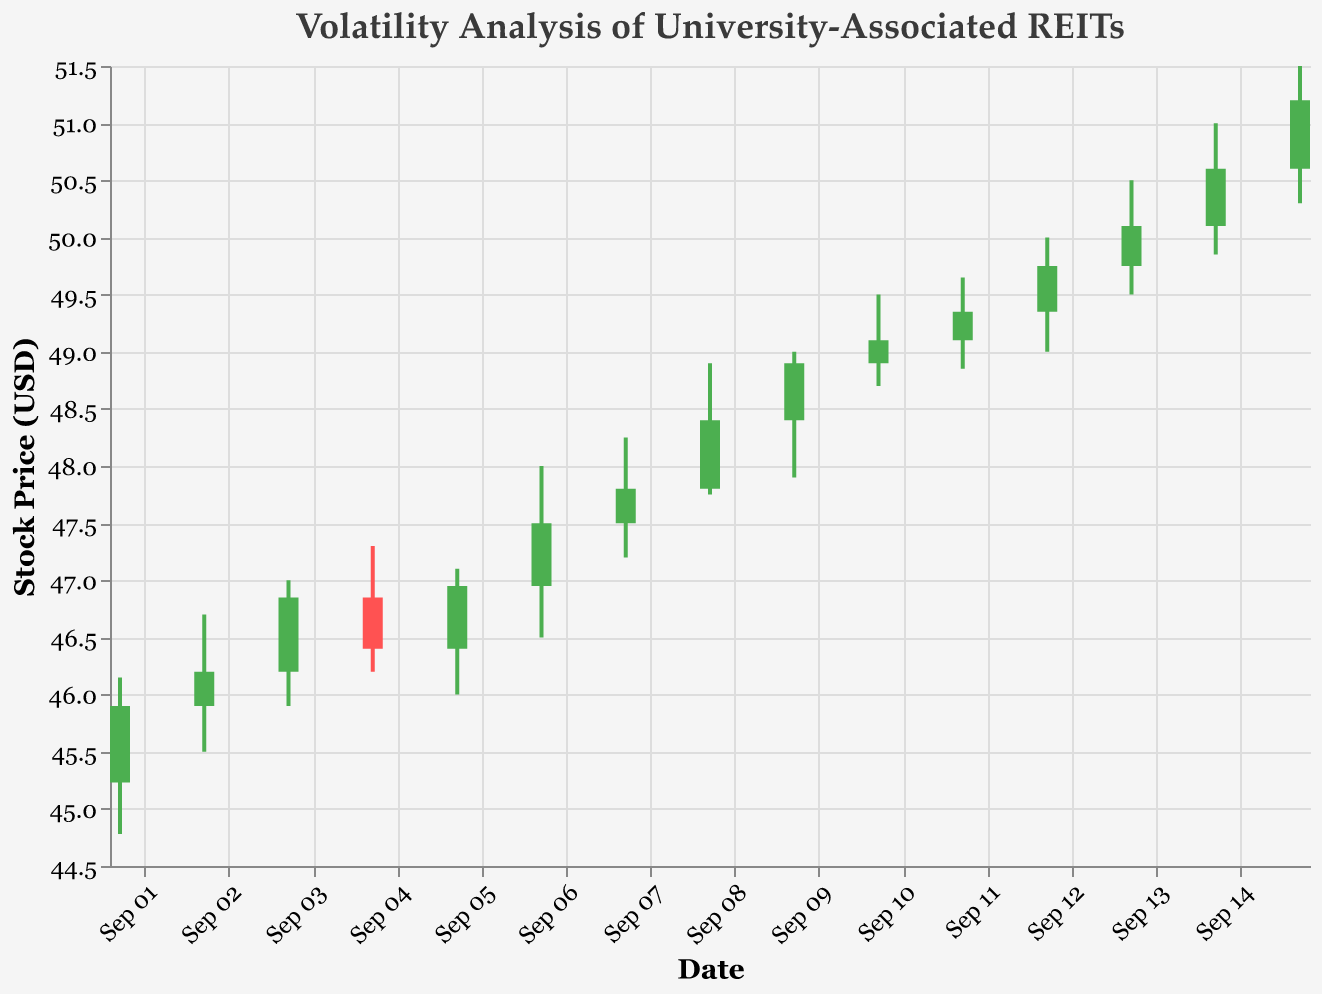What's the title of the plot? The title of the plot is displayed at the top and reads "Volatility Analysis of University-Associated REITs".
Answer: Volatility Analysis of University-Associated REITs What are the axes labels featured in the chart? The x-axis is labeled "Date" and the y-axis is labeled "Stock Price (USD)".
Answer: Date; Stock Price (USD) How did the stock price change on September 07, 2023? On September 07, the stock opened at $47.50, reached a high of $48.25, dropped to a low of $47.20, and closed at $47.80.
Answer: Opened at $47.50, Closed at $47.80 What is the highest stock price recorded in the data set? The highest price can be found by identifying the peak value in the "High" column. The peak is $51.50 on September 15, 2023.
Answer: $51.50 How many days show a closing price higher than the opening price? Count the number of days where the closing price is higher than the opening price. These days show a green bar in the candlestick plot: 8 days in total.
Answer: 8 days Which day experienced the highest trading volume and what was the value? Look at the "Volume" data to find the highest value, which is 1,650,000 on September 15, 2023.
Answer: September 15, 2023, Volume is 1,650,000 What was the average closing price over the entire period? To calculate the average, sum all the closing prices and divide by the number of days (15). The sum of the closing prices is $722.30, hence the average is $722.30 / 15 ≈ $48.15.
Answer: $48.15 Did the stock price close higher or lower on September 12, 2023, compared to the previous day (September 11, 2023)? Compare the closing prices: September 12 ($49.75) with September 11 ($49.35). The stock closed higher on September 12.
Answer: Higher Which date showed the most volatility in terms of the difference between the high and low prices, and what was that difference? Calculate the difference (High - Low) for each date to find the largest difference. The largest difference is on September 15 with $51.50 - $50.30 = $1.20.
Answer: September 15, $1.20 During which period did the stock price show a consistent upward trend, judging by consecutive daily closing prices? Look at the closing prices and identify periods with consecutive increases. From September 11 to September 15, the stock price increased daily from $49.35 to $51.20.
Answer: September 11 to September 15 